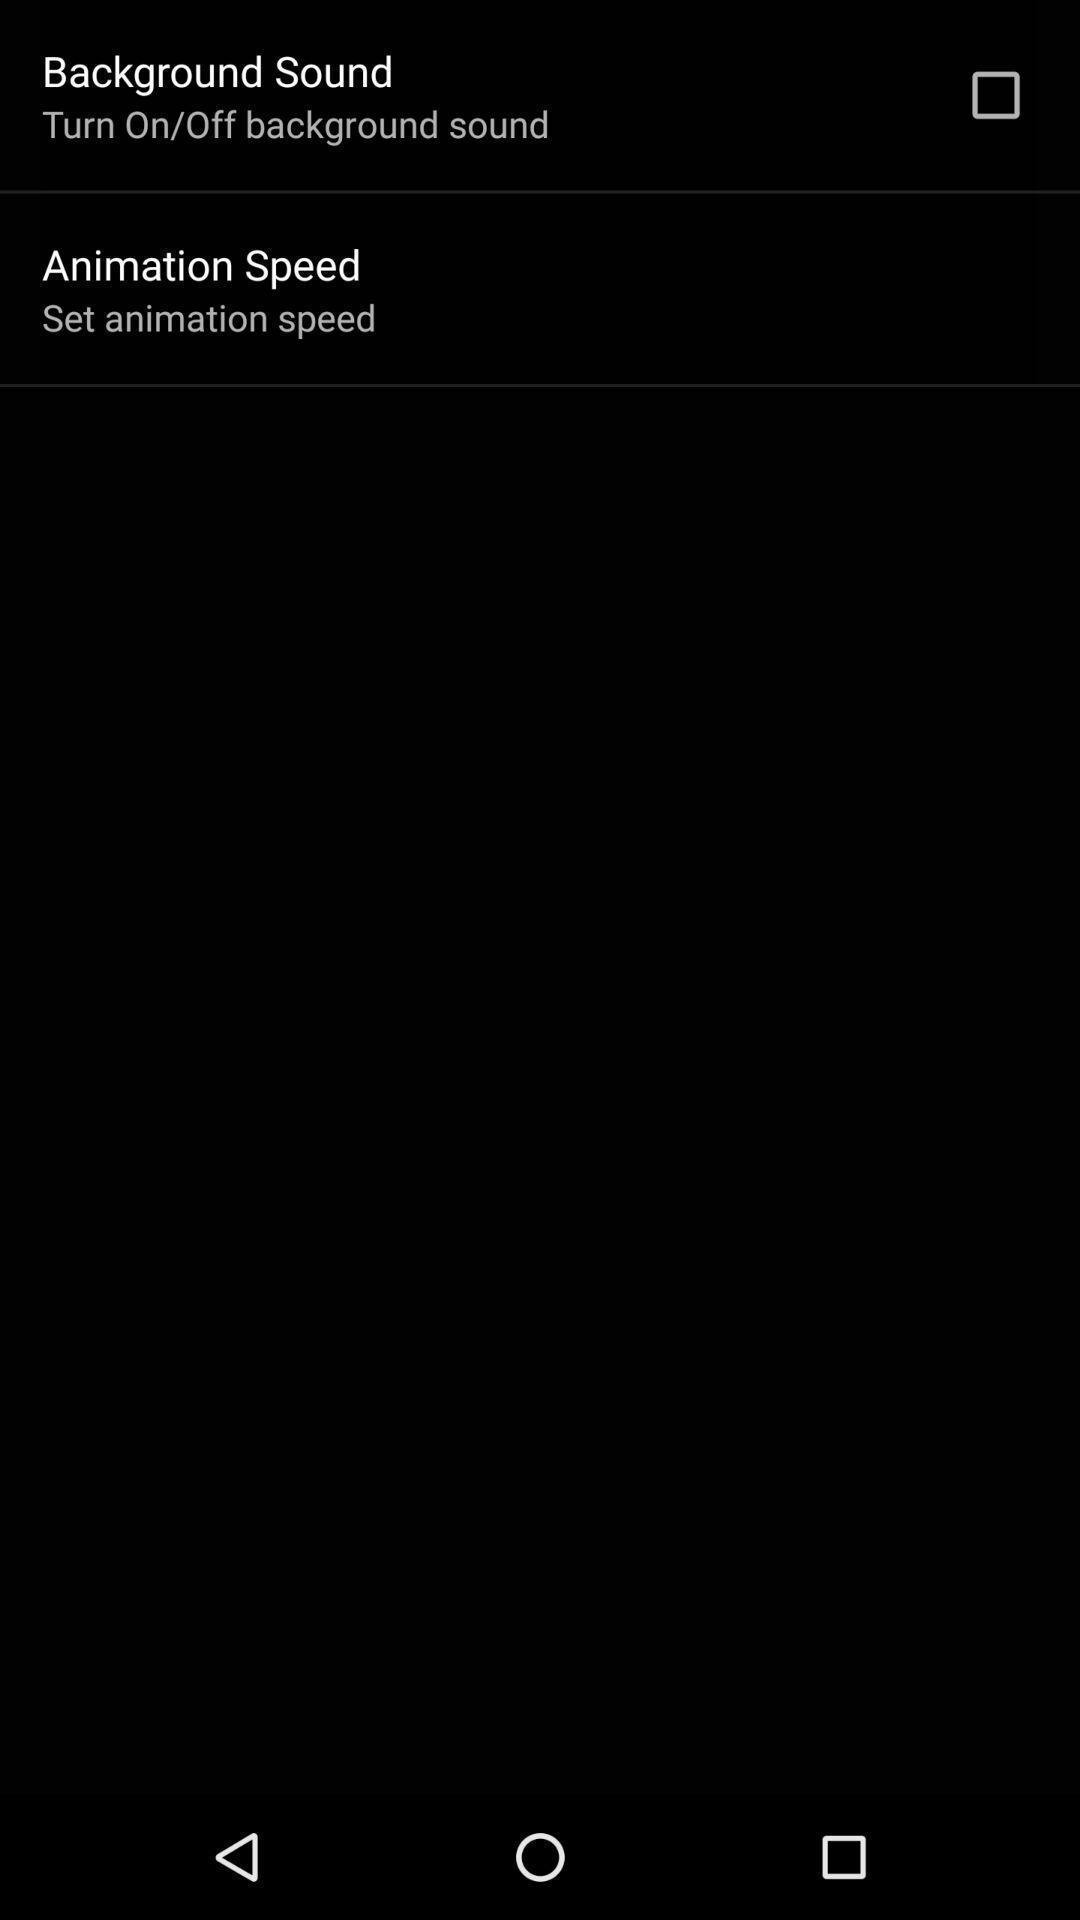What is the overall content of this screenshot? Two sound settings are displaying in the page. 